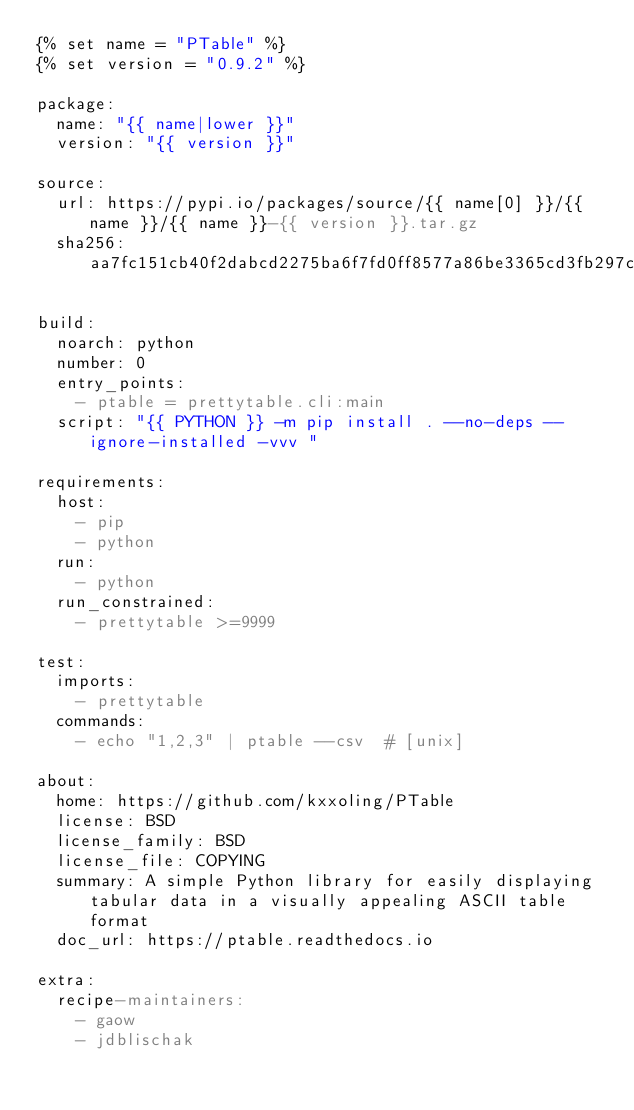Convert code to text. <code><loc_0><loc_0><loc_500><loc_500><_YAML_>{% set name = "PTable" %}
{% set version = "0.9.2" %}

package:
  name: "{{ name|lower }}"
  version: "{{ version }}"

source:
  url: https://pypi.io/packages/source/{{ name[0] }}/{{ name }}/{{ name }}-{{ version }}.tar.gz
  sha256: aa7fc151cb40f2dabcd2275ba6f7fd0ff8577a86be3365cd3fb297cbe09cc292

build:
  noarch: python
  number: 0
  entry_points:
    - ptable = prettytable.cli:main
  script: "{{ PYTHON }} -m pip install . --no-deps --ignore-installed -vvv "

requirements:
  host:
    - pip
    - python
  run:
    - python
  run_constrained:
    - prettytable >=9999

test:
  imports:
    - prettytable
  commands:
    - echo "1,2,3" | ptable --csv  # [unix]

about:
  home: https://github.com/kxxoling/PTable
  license: BSD
  license_family: BSD
  license_file: COPYING
  summary: A simple Python library for easily displaying tabular data in a visually appealing ASCII table format
  doc_url: https://ptable.readthedocs.io

extra:
  recipe-maintainers:
    - gaow
    - jdblischak
</code> 